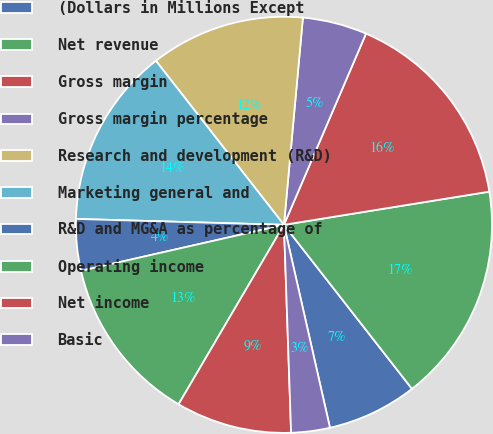Convert chart to OTSL. <chart><loc_0><loc_0><loc_500><loc_500><pie_chart><fcel>(Dollars in Millions Except<fcel>Net revenue<fcel>Gross margin<fcel>Gross margin percentage<fcel>Research and development (R&D)<fcel>Marketing general and<fcel>R&D and MG&A as percentage of<fcel>Operating income<fcel>Net income<fcel>Basic<nl><fcel>7.0%<fcel>17.0%<fcel>16.0%<fcel>5.0%<fcel>12.0%<fcel>14.0%<fcel>4.0%<fcel>13.0%<fcel>9.0%<fcel>3.0%<nl></chart> 